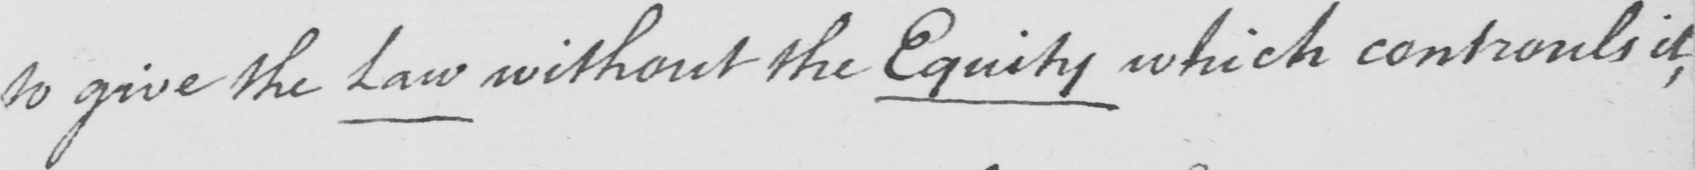What is written in this line of handwriting? to give the Law without the Equity which controls it , 